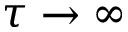<formula> <loc_0><loc_0><loc_500><loc_500>\tau \to \infty</formula> 